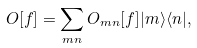Convert formula to latex. <formula><loc_0><loc_0><loc_500><loc_500>O [ f ] = \sum _ { m n } O _ { m n } [ f ] | m \rangle \langle n | ,</formula> 